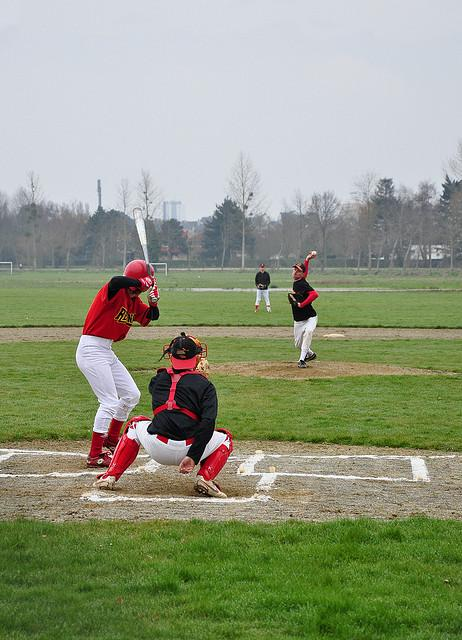What is the opposite form of this pitch?

Choices:
A) lefthand
B) sidehand
C) underhand
D) overhand underhand 